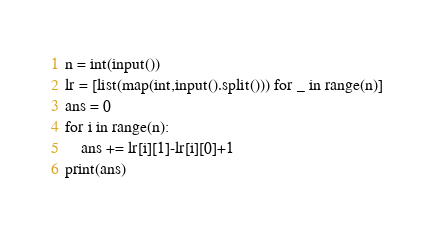Convert code to text. <code><loc_0><loc_0><loc_500><loc_500><_Python_>n = int(input())
lr = [list(map(int,input().split())) for _ in range(n)]
ans = 0
for i in range(n):
    ans += lr[i][1]-lr[i][0]+1
print(ans)</code> 